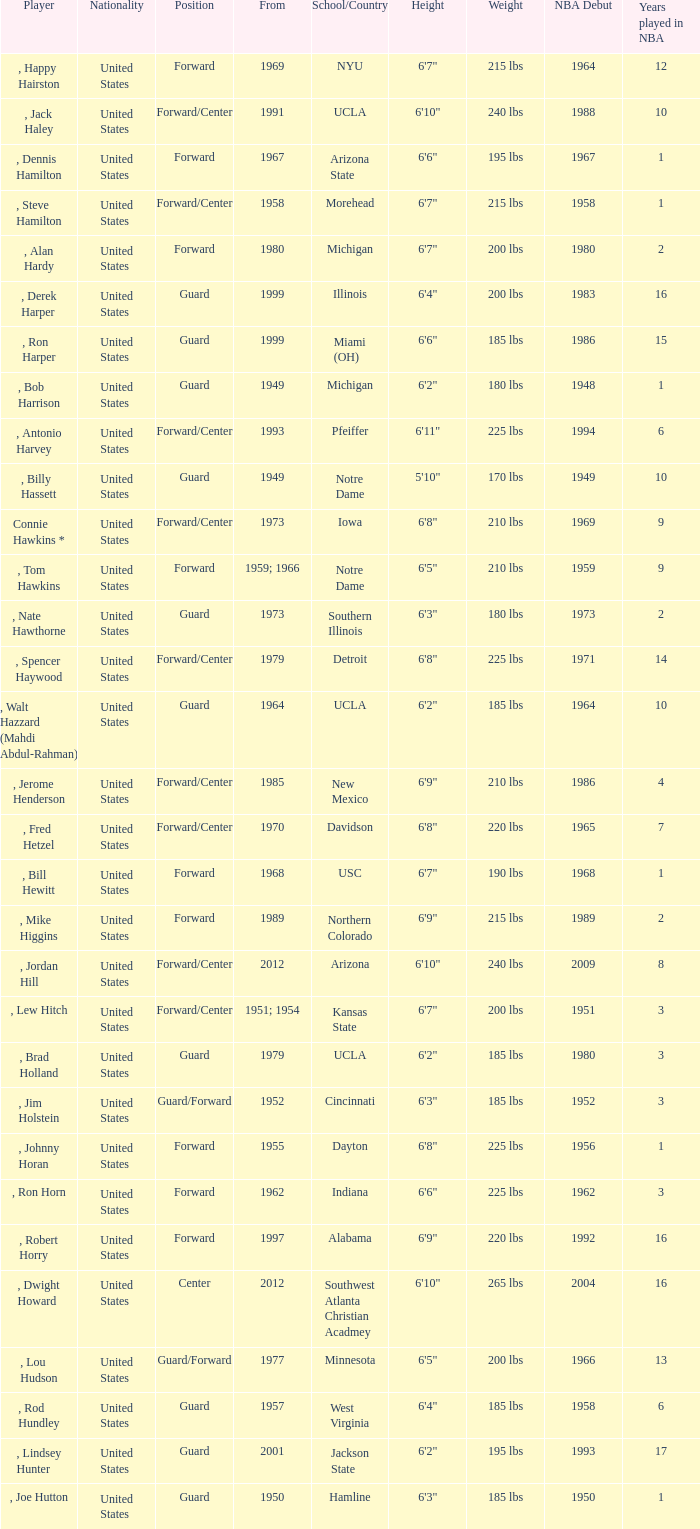Which school has the player that started in 1958? Morehead. 